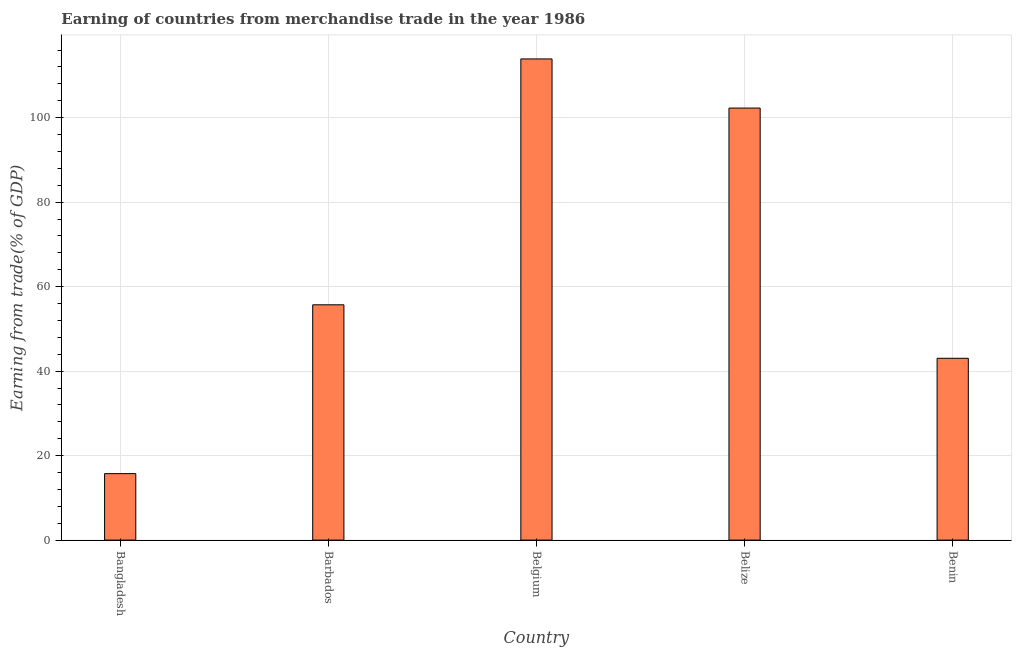Does the graph contain any zero values?
Your answer should be very brief. No. Does the graph contain grids?
Give a very brief answer. Yes. What is the title of the graph?
Ensure brevity in your answer.  Earning of countries from merchandise trade in the year 1986. What is the label or title of the Y-axis?
Your answer should be compact. Earning from trade(% of GDP). What is the earning from merchandise trade in Bangladesh?
Provide a succinct answer. 15.73. Across all countries, what is the maximum earning from merchandise trade?
Make the answer very short. 113.89. Across all countries, what is the minimum earning from merchandise trade?
Keep it short and to the point. 15.73. What is the sum of the earning from merchandise trade?
Give a very brief answer. 330.61. What is the difference between the earning from merchandise trade in Bangladesh and Barbados?
Provide a succinct answer. -39.96. What is the average earning from merchandise trade per country?
Provide a succinct answer. 66.12. What is the median earning from merchandise trade?
Offer a terse response. 55.69. In how many countries, is the earning from merchandise trade greater than 96 %?
Offer a terse response. 2. What is the ratio of the earning from merchandise trade in Barbados to that in Benin?
Provide a succinct answer. 1.29. Is the difference between the earning from merchandise trade in Barbados and Belgium greater than the difference between any two countries?
Your answer should be very brief. No. What is the difference between the highest and the second highest earning from merchandise trade?
Your answer should be very brief. 11.63. Is the sum of the earning from merchandise trade in Barbados and Benin greater than the maximum earning from merchandise trade across all countries?
Offer a very short reply. No. What is the difference between the highest and the lowest earning from merchandise trade?
Give a very brief answer. 98.16. In how many countries, is the earning from merchandise trade greater than the average earning from merchandise trade taken over all countries?
Ensure brevity in your answer.  2. Are all the bars in the graph horizontal?
Your answer should be compact. No. What is the Earning from trade(% of GDP) in Bangladesh?
Offer a very short reply. 15.73. What is the Earning from trade(% of GDP) in Barbados?
Offer a very short reply. 55.69. What is the Earning from trade(% of GDP) in Belgium?
Provide a short and direct response. 113.89. What is the Earning from trade(% of GDP) of Belize?
Give a very brief answer. 102.26. What is the Earning from trade(% of GDP) of Benin?
Provide a succinct answer. 43.04. What is the difference between the Earning from trade(% of GDP) in Bangladesh and Barbados?
Your response must be concise. -39.96. What is the difference between the Earning from trade(% of GDP) in Bangladesh and Belgium?
Your answer should be very brief. -98.16. What is the difference between the Earning from trade(% of GDP) in Bangladesh and Belize?
Your answer should be very brief. -86.53. What is the difference between the Earning from trade(% of GDP) in Bangladesh and Benin?
Your answer should be very brief. -27.3. What is the difference between the Earning from trade(% of GDP) in Barbados and Belgium?
Keep it short and to the point. -58.2. What is the difference between the Earning from trade(% of GDP) in Barbados and Belize?
Offer a terse response. -46.57. What is the difference between the Earning from trade(% of GDP) in Barbados and Benin?
Your response must be concise. 12.66. What is the difference between the Earning from trade(% of GDP) in Belgium and Belize?
Offer a terse response. 11.63. What is the difference between the Earning from trade(% of GDP) in Belgium and Benin?
Your response must be concise. 70.85. What is the difference between the Earning from trade(% of GDP) in Belize and Benin?
Give a very brief answer. 59.22. What is the ratio of the Earning from trade(% of GDP) in Bangladesh to that in Barbados?
Offer a very short reply. 0.28. What is the ratio of the Earning from trade(% of GDP) in Bangladesh to that in Belgium?
Offer a terse response. 0.14. What is the ratio of the Earning from trade(% of GDP) in Bangladesh to that in Belize?
Provide a short and direct response. 0.15. What is the ratio of the Earning from trade(% of GDP) in Bangladesh to that in Benin?
Offer a terse response. 0.37. What is the ratio of the Earning from trade(% of GDP) in Barbados to that in Belgium?
Your answer should be very brief. 0.49. What is the ratio of the Earning from trade(% of GDP) in Barbados to that in Belize?
Your answer should be very brief. 0.55. What is the ratio of the Earning from trade(% of GDP) in Barbados to that in Benin?
Ensure brevity in your answer.  1.29. What is the ratio of the Earning from trade(% of GDP) in Belgium to that in Belize?
Provide a succinct answer. 1.11. What is the ratio of the Earning from trade(% of GDP) in Belgium to that in Benin?
Keep it short and to the point. 2.65. What is the ratio of the Earning from trade(% of GDP) in Belize to that in Benin?
Make the answer very short. 2.38. 